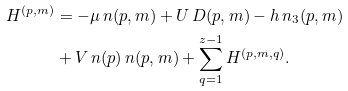Convert formula to latex. <formula><loc_0><loc_0><loc_500><loc_500>H ^ { ( p , m ) } & = - \mu \, n ( p , m ) + U \, D ( p , m ) - h \, n _ { 3 } ( p , m ) \\ & + V \, n ( p ) \, n ( p , m ) + \sum _ { q = 1 } ^ { z - 1 } H ^ { ( p , m , q ) } .</formula> 